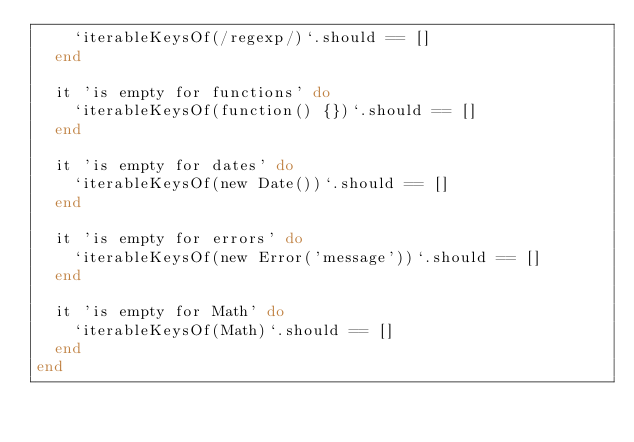Convert code to text. <code><loc_0><loc_0><loc_500><loc_500><_Ruby_>    `iterableKeysOf(/regexp/)`.should == []
  end

  it 'is empty for functions' do
    `iterableKeysOf(function() {})`.should == []
  end

  it 'is empty for dates' do
    `iterableKeysOf(new Date())`.should == []
  end

  it 'is empty for errors' do
    `iterableKeysOf(new Error('message'))`.should == []
  end

  it 'is empty for Math' do
    `iterableKeysOf(Math)`.should == []
  end
end
</code> 